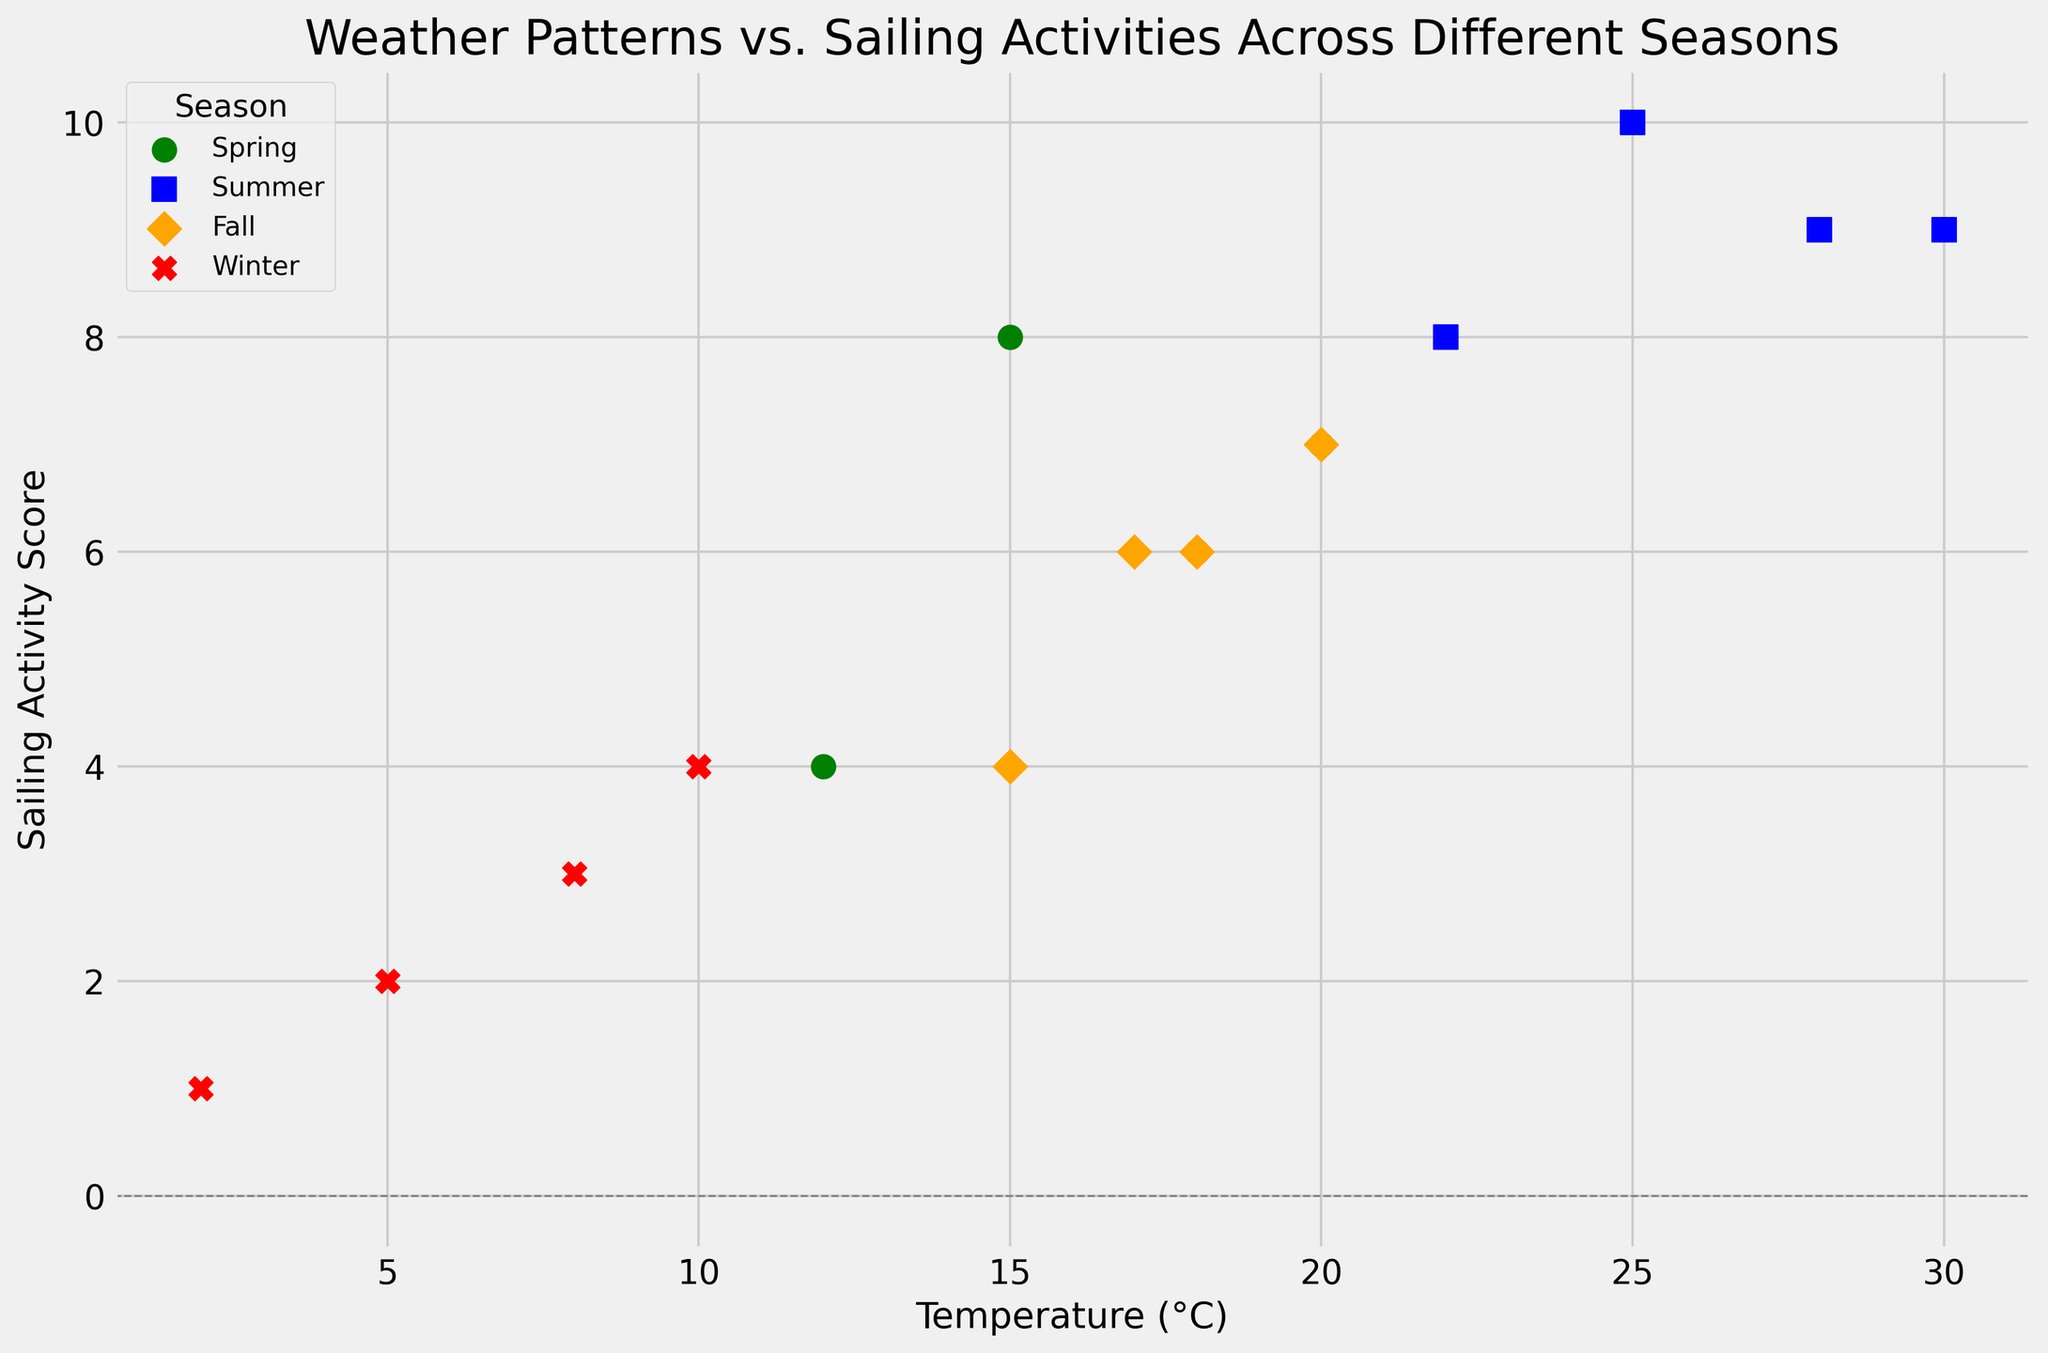What's the overall trend between temperature and sailing activity across different seasons? From the scatter plot, we see that higher temperatures are generally associated with higher sailing activity scores. Specifically, during the summer, the highest temperatures (25-30°C) correspond with the highest sailing activities (scores 8-10). Conversely, in winter, lower temperatures (2-10°C) correlate with lower sailing activities (scores 1-4). Spring and fall show moderate temperatures and activities.
Answer: Positive correlation between temperature and sailing activity Which season has the highest maximum sailing activity score? By examining the season-specific markers, we see that summer (marked by blue squares) has the highest maximum sailing activity score of 10.
Answer: Summer Compare Spring and Winter in terms of the average sailing activity score. Spring values: 8, 6, 4, 7. Their sum is 25, and the average is 25/4 = 6.25. Winter values: 2, 3, 1, 4. Their sum is 10, and the average is 10/4 = 2.5. Therefore, the average sailing activity score in Spring (6.25) is higher than in Winter (2.5).
Answer: Spring Which season shows the most diverse range of sailing activity scores? By observing the scatter plot, Spring has a range of scores from 4 to 8, Summer from 8 to 10, Fall from 4 to 7, and Winter from 1 to 4. Spring shows a range of 4 (from 4 to 8), indicating the most diverse range of sailing activity scores.
Answer: Spring How does sailing activity in Fall compare to that in Spring in terms of spread? The spread in Spring (4 to 8) is greater than that in Fall (4 to 7). The total spread for Spring is 4, and for Fall, it is 3. Spring shows a larger spread in sailing activity compared to Fall.
Answer: Spring What is the lowest temperature associated with the highest sailing activity score? The highest sailing activity score is 10. This score is seen in Summer with the temperature of 25°C.
Answer: 25°C Are there any instances when precipitation is non-zero but sailing activity is at its maximum? By looking at the scatter plot points and considering precipitation, we see that the highest sailing activity score (10) occurs in Summer at 25°C and 0 precipitation. Therefore, high sailing activity doesn't coincide with non-zero precipitation.
Answer: No What is the relationship between wind speed and sailing activities in Winter? Winter points (red X) with wind speeds 15, 12, 18, 10 have corresponding sailing activities 2, 3, 1, 4. There is no clear direct correlation as sailing activity does not consistently increase or decrease with wind speed in Winter.
Answer: No clear correlation 